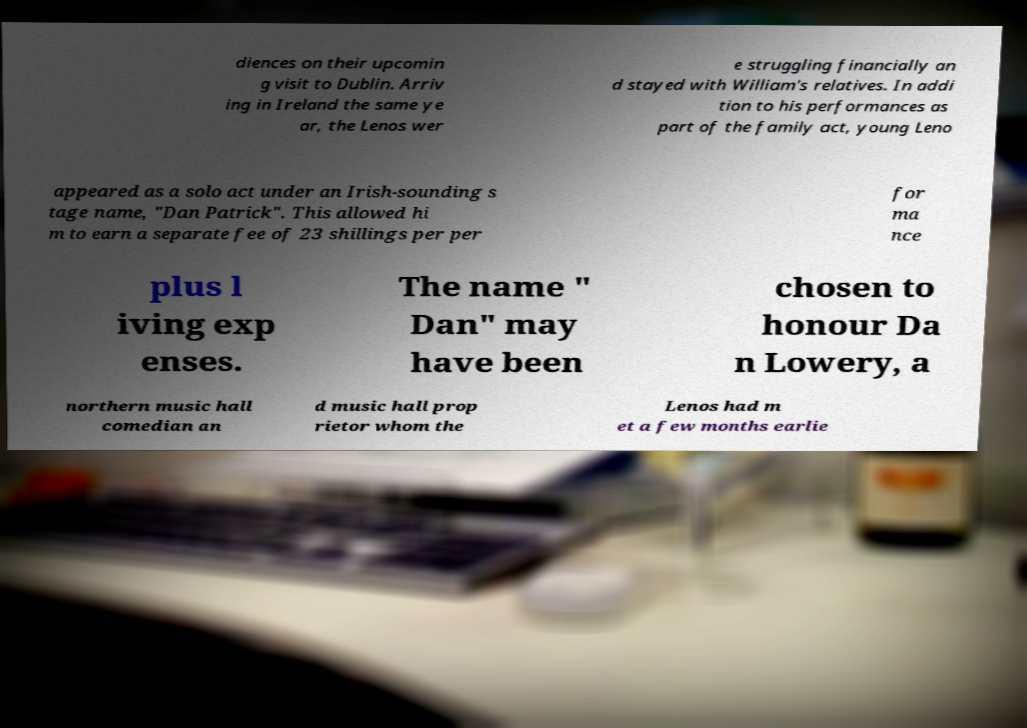Please identify and transcribe the text found in this image. diences on their upcomin g visit to Dublin. Arriv ing in Ireland the same ye ar, the Lenos wer e struggling financially an d stayed with William's relatives. In addi tion to his performances as part of the family act, young Leno appeared as a solo act under an Irish-sounding s tage name, "Dan Patrick". This allowed hi m to earn a separate fee of 23 shillings per per for ma nce plus l iving exp enses. The name " Dan" may have been chosen to honour Da n Lowery, a northern music hall comedian an d music hall prop rietor whom the Lenos had m et a few months earlie 